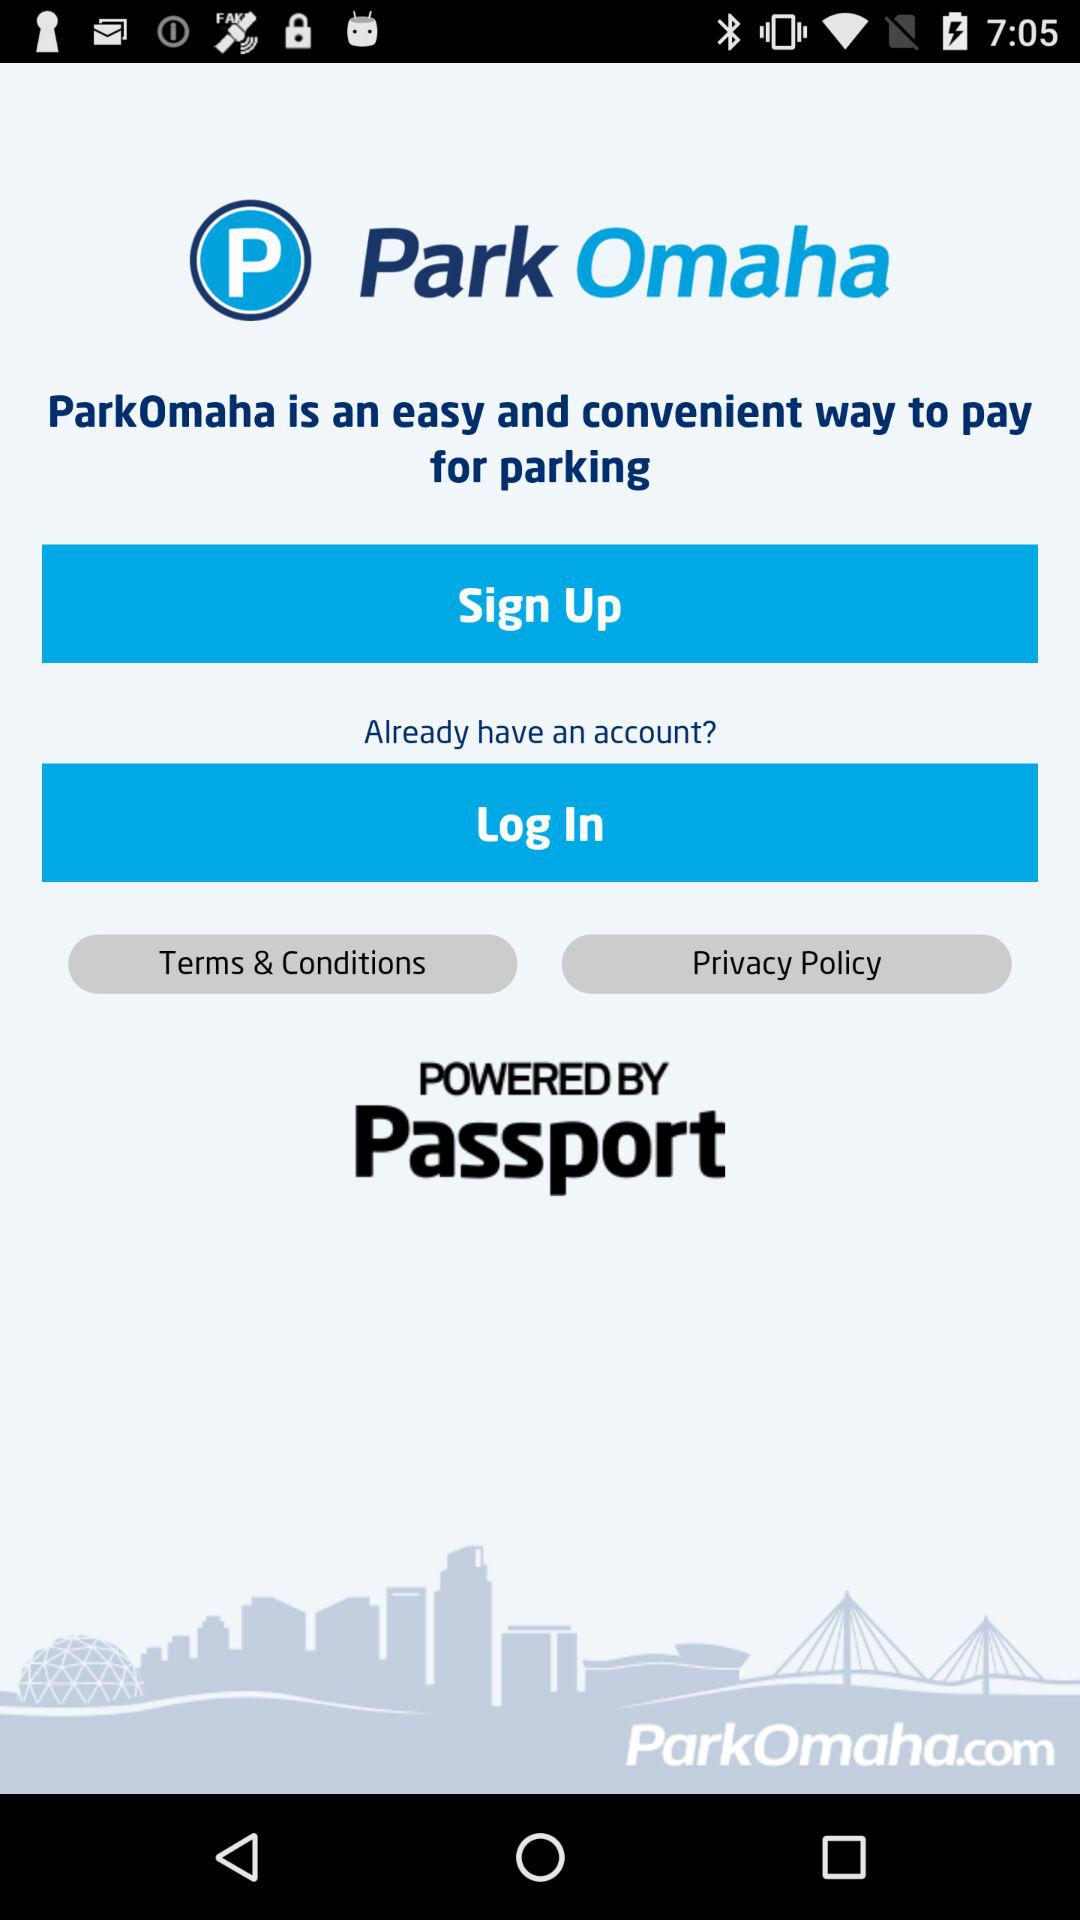What is the website name? The website name is ParkOmaha.com. 